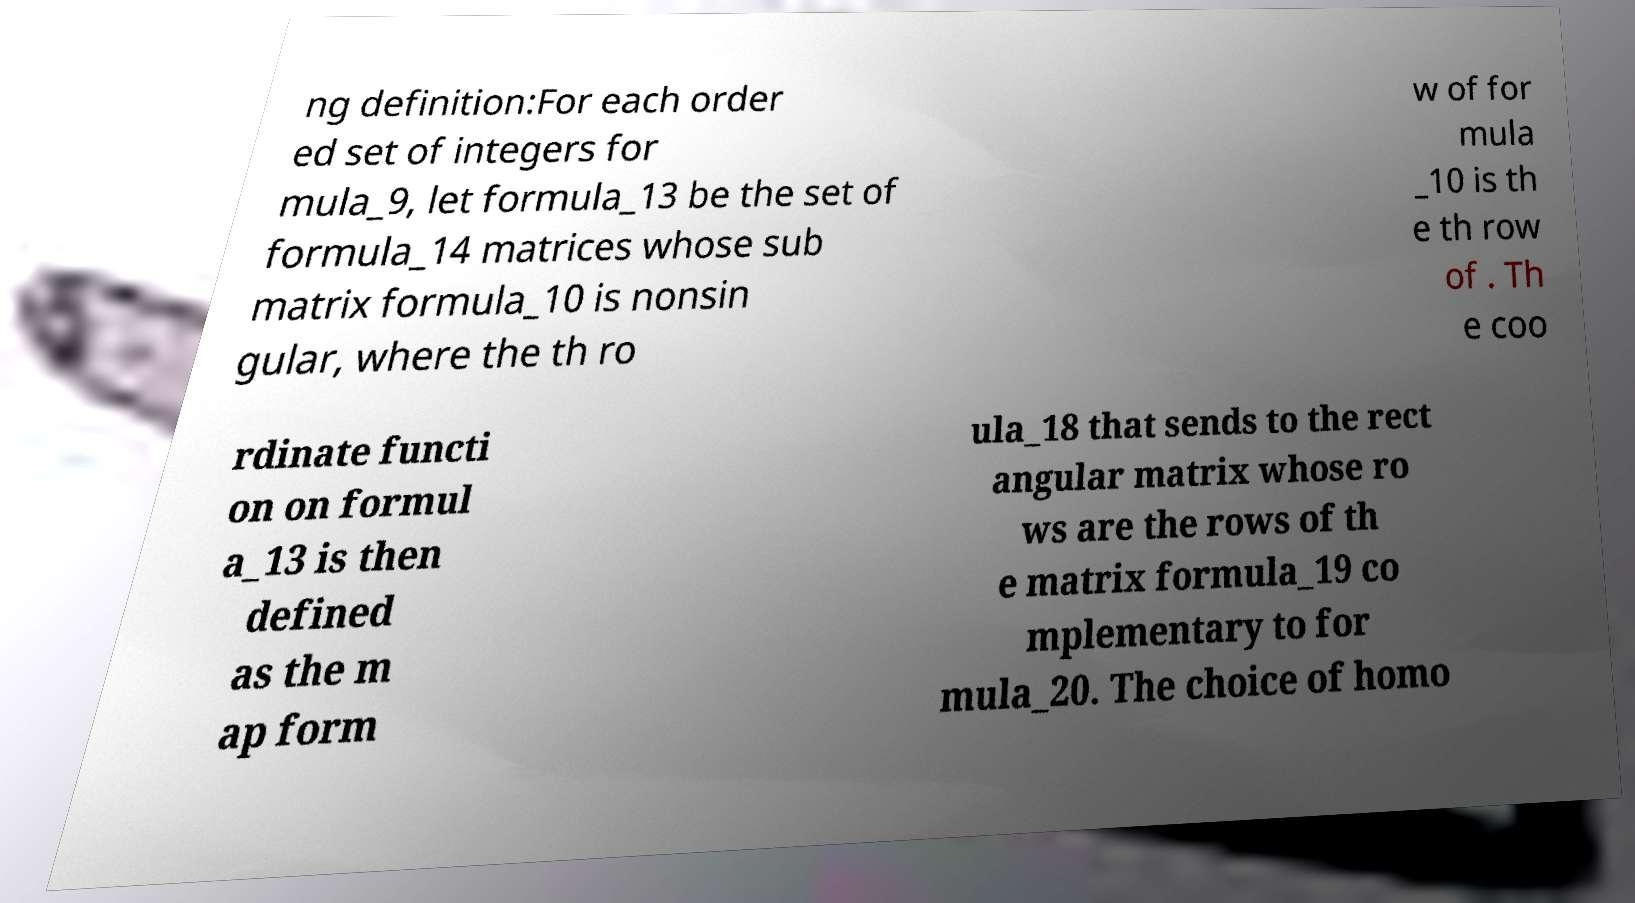Can you read and provide the text displayed in the image?This photo seems to have some interesting text. Can you extract and type it out for me? ng definition:For each order ed set of integers for mula_9, let formula_13 be the set of formula_14 matrices whose sub matrix formula_10 is nonsin gular, where the th ro w of for mula _10 is th e th row of . Th e coo rdinate functi on on formul a_13 is then defined as the m ap form ula_18 that sends to the rect angular matrix whose ro ws are the rows of th e matrix formula_19 co mplementary to for mula_20. The choice of homo 